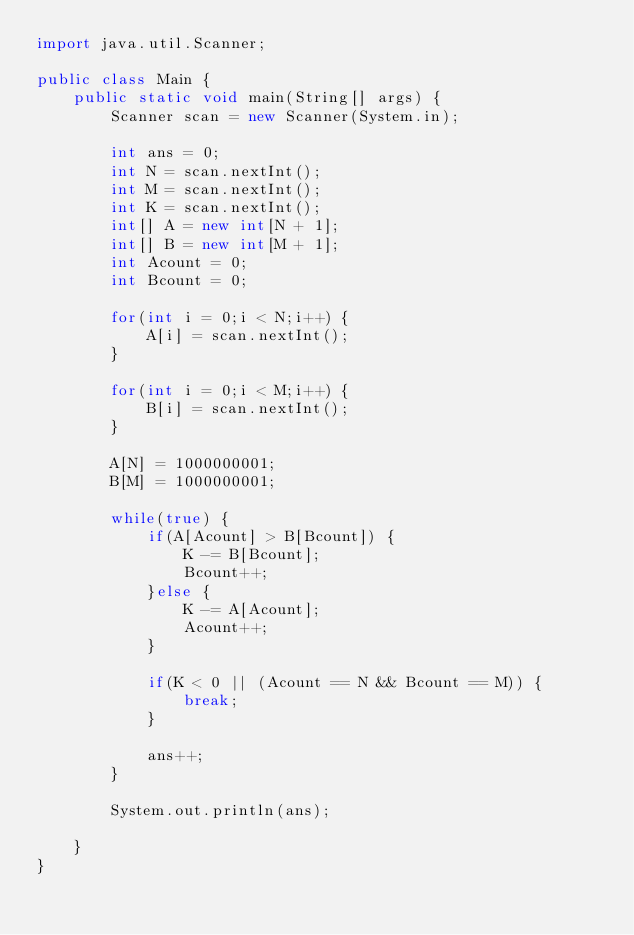<code> <loc_0><loc_0><loc_500><loc_500><_Java_>import java.util.Scanner;

public class Main {
	public static void main(String[] args) {
		Scanner scan = new Scanner(System.in);

		int ans = 0;
		int N = scan.nextInt();
		int M = scan.nextInt();
		int K = scan.nextInt();
		int[] A = new int[N + 1];
		int[] B = new int[M + 1];
		int Acount = 0;
		int Bcount = 0;

		for(int i = 0;i < N;i++) {
			A[i] = scan.nextInt();
		}

		for(int i = 0;i < M;i++) {
			B[i] = scan.nextInt();
		}

		A[N] = 1000000001;
		B[M] = 1000000001;

		while(true) {
			if(A[Acount] > B[Bcount]) {
				K -= B[Bcount];
				Bcount++;
			}else {
				K -= A[Acount];
				Acount++;
			}

			if(K < 0 || (Acount == N && Bcount == M)) {
				break;
			}

			ans++;
		}

		System.out.println(ans);

	}
}</code> 